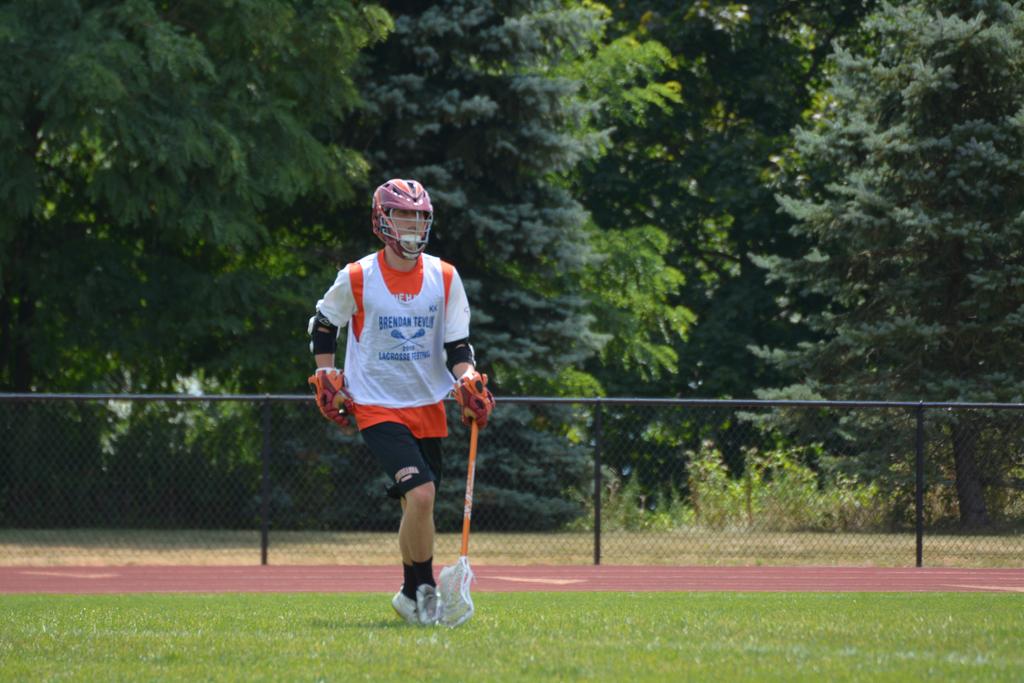What sport is on the shirt?
Provide a succinct answer. Lacrosse. 